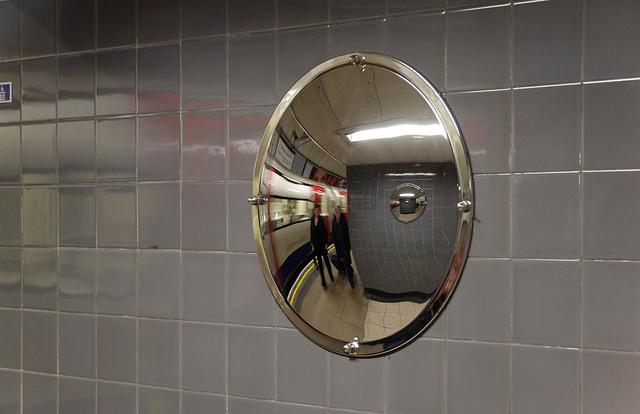What room is this?
Short answer required. Bathroom. Is this in a bathroom?
Give a very brief answer. No. What is reflecting in the mirror?
Be succinct. People. 